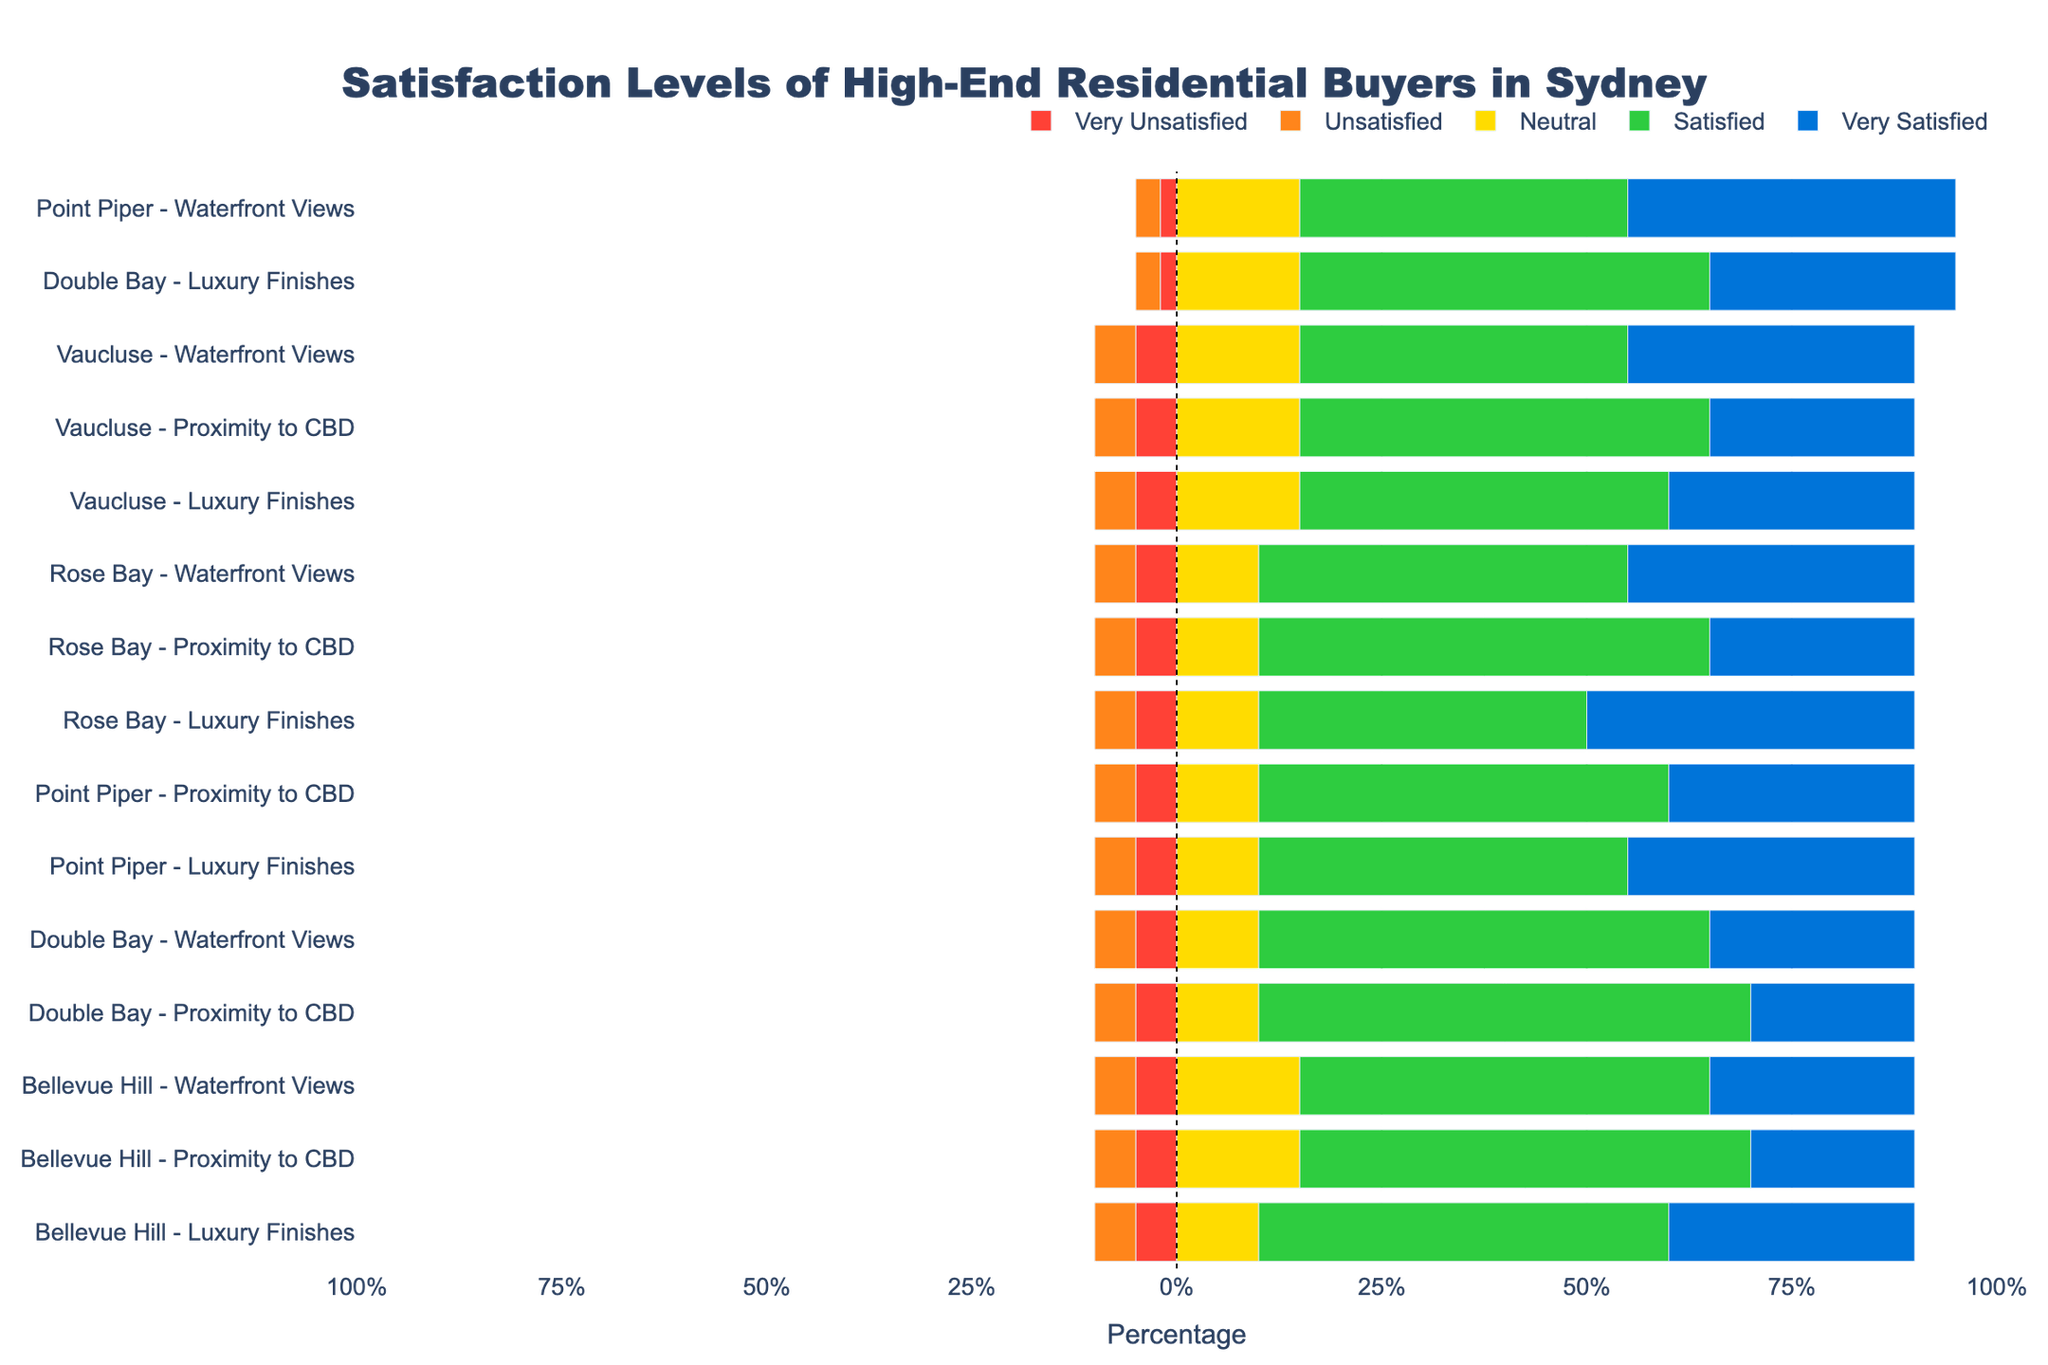Which neighbourhood shows the highest level of "Very Satisfied" response for "Waterfront Views"? Find the "Waterfront Views" rows for all neighbourhoods, then identify the one with the highest "Very Satisfied" percentage. Point Piper has 40%, higher than Bellevue Hill, Vaucluse, Double Bay, and Rose Bay.
Answer: Point Piper Which amenity has the lowest satisfaction level (sum of Unsatisfied and Very Unsatisfied) across all neighbourhoods? Sum the percentages of Unsatisfied and Very Unsatisfied for each amenity across all neighbourhoods. "Luxury Finishes" and "Proximity to CBD" have the lowest, but "Luxury Finishes" is slightly lower overall.
Answer: Luxury Finishes Compare the levels of Neutral satisfaction for "Proximity to CBD" between Point Piper and Vaucluse. Which neighbourhood has a higher percentage? Look at the "Neutral" column for "Proximity to CBD" in both Point Piper and Vaucluse. Point Piper has 10%, and Vaucluse has 15%, so Vaucluse is higher.
Answer: Vaucluse How does the satisfaction level of "Satisfied" for "Luxury Finishes" in Rose Bay compare to Double Bay? Check the "Satisfied" percentage for "Luxury Finishes" in Rose Bay (40%) and Double Bay (50%). Double Bay has a higher percentage.
Answer: Double Bay Which neighbourhood has the most diverse levels of satisfaction (total range from Very Unsatisfied to Very Satisfied) for "Proximity to CBD"? Check the range (Very Satisfied - Very Unsatisfied) for "Proximity to CBD" satisfaction levels in each neighbourhood. Double Bay has a range from 20% to 60%.
Answer: Double Bay What's the average satisfaction level of "Satisfied" across all neighbourhoods and amenities? Sum up all the percentages for "Satisfied" across the rows and divide by the total number of rows (15). Total = 50+55+45+50+50+40+50+55+50+50+55+55+60+45+50 = 710, average = 710/15 = 47.33%.
Answer: 47.33% In which neighbourhood do buyers show the highest dissatisfaction (sum of Unsatisfied and Very Unsatisfied) for "Waterfront Views"? Calculate the sum of Unsatisfied and Very Unsatisfied for "Waterfront Views" in each neighbourhood. Double Bay has 10% Unsatisfied and 5% Very Unsatisfied, totaling 15%, which is the highest.
Answer: Double Bay 